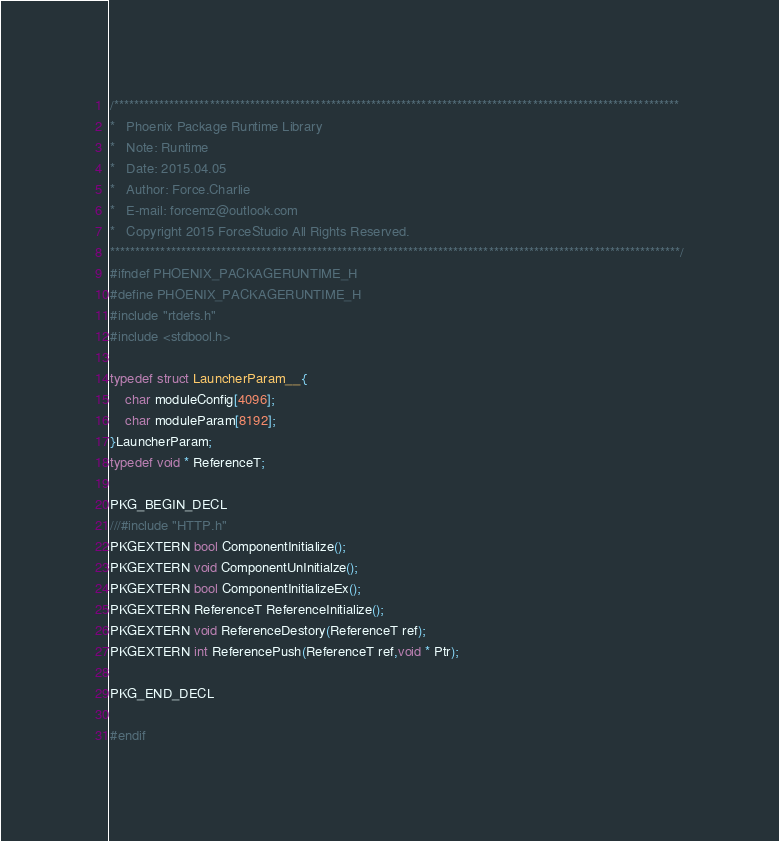<code> <loc_0><loc_0><loc_500><loc_500><_C_>/****************************************************************************************************************
*   Phoenix Package Runtime Library
*   Note: Runtime
*   Date: 2015.04.05
*   Author: Force.Charlie
*   E-mail: forcemz@outlook.com
*   Copyright 2015 ForceStudio All Rights Reserved.
*****************************************************************************************************************/
#ifndef PHOENIX_PACKAGERUNTIME_H
#define PHOENIX_PACKAGERUNTIME_H
#include "rtdefs.h"
#include <stdbool.h>

typedef struct LauncherParam__{
    char moduleConfig[4096];
    char moduleParam[8192];
}LauncherParam;
typedef void * ReferenceT;

PKG_BEGIN_DECL
///#include "HTTP.h"
PKGEXTERN bool ComponentInitialize();
PKGEXTERN void ComponentUnInitialze();
PKGEXTERN bool ComponentInitializeEx();
PKGEXTERN ReferenceT ReferenceInitialize();
PKGEXTERN void ReferenceDestory(ReferenceT ref);
PKGEXTERN int ReferencePush(ReferenceT ref,void * Ptr);

PKG_END_DECL

#endif
</code> 